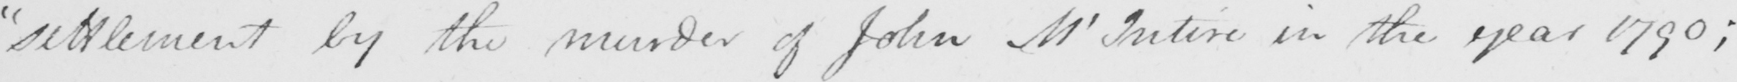Can you tell me what this handwritten text says? " settlement by the murder of John McIntire in the year 1790 ; 